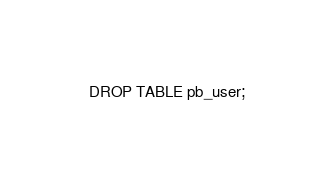<code> <loc_0><loc_0><loc_500><loc_500><_SQL_>DROP TABLE pb_user;
</code> 